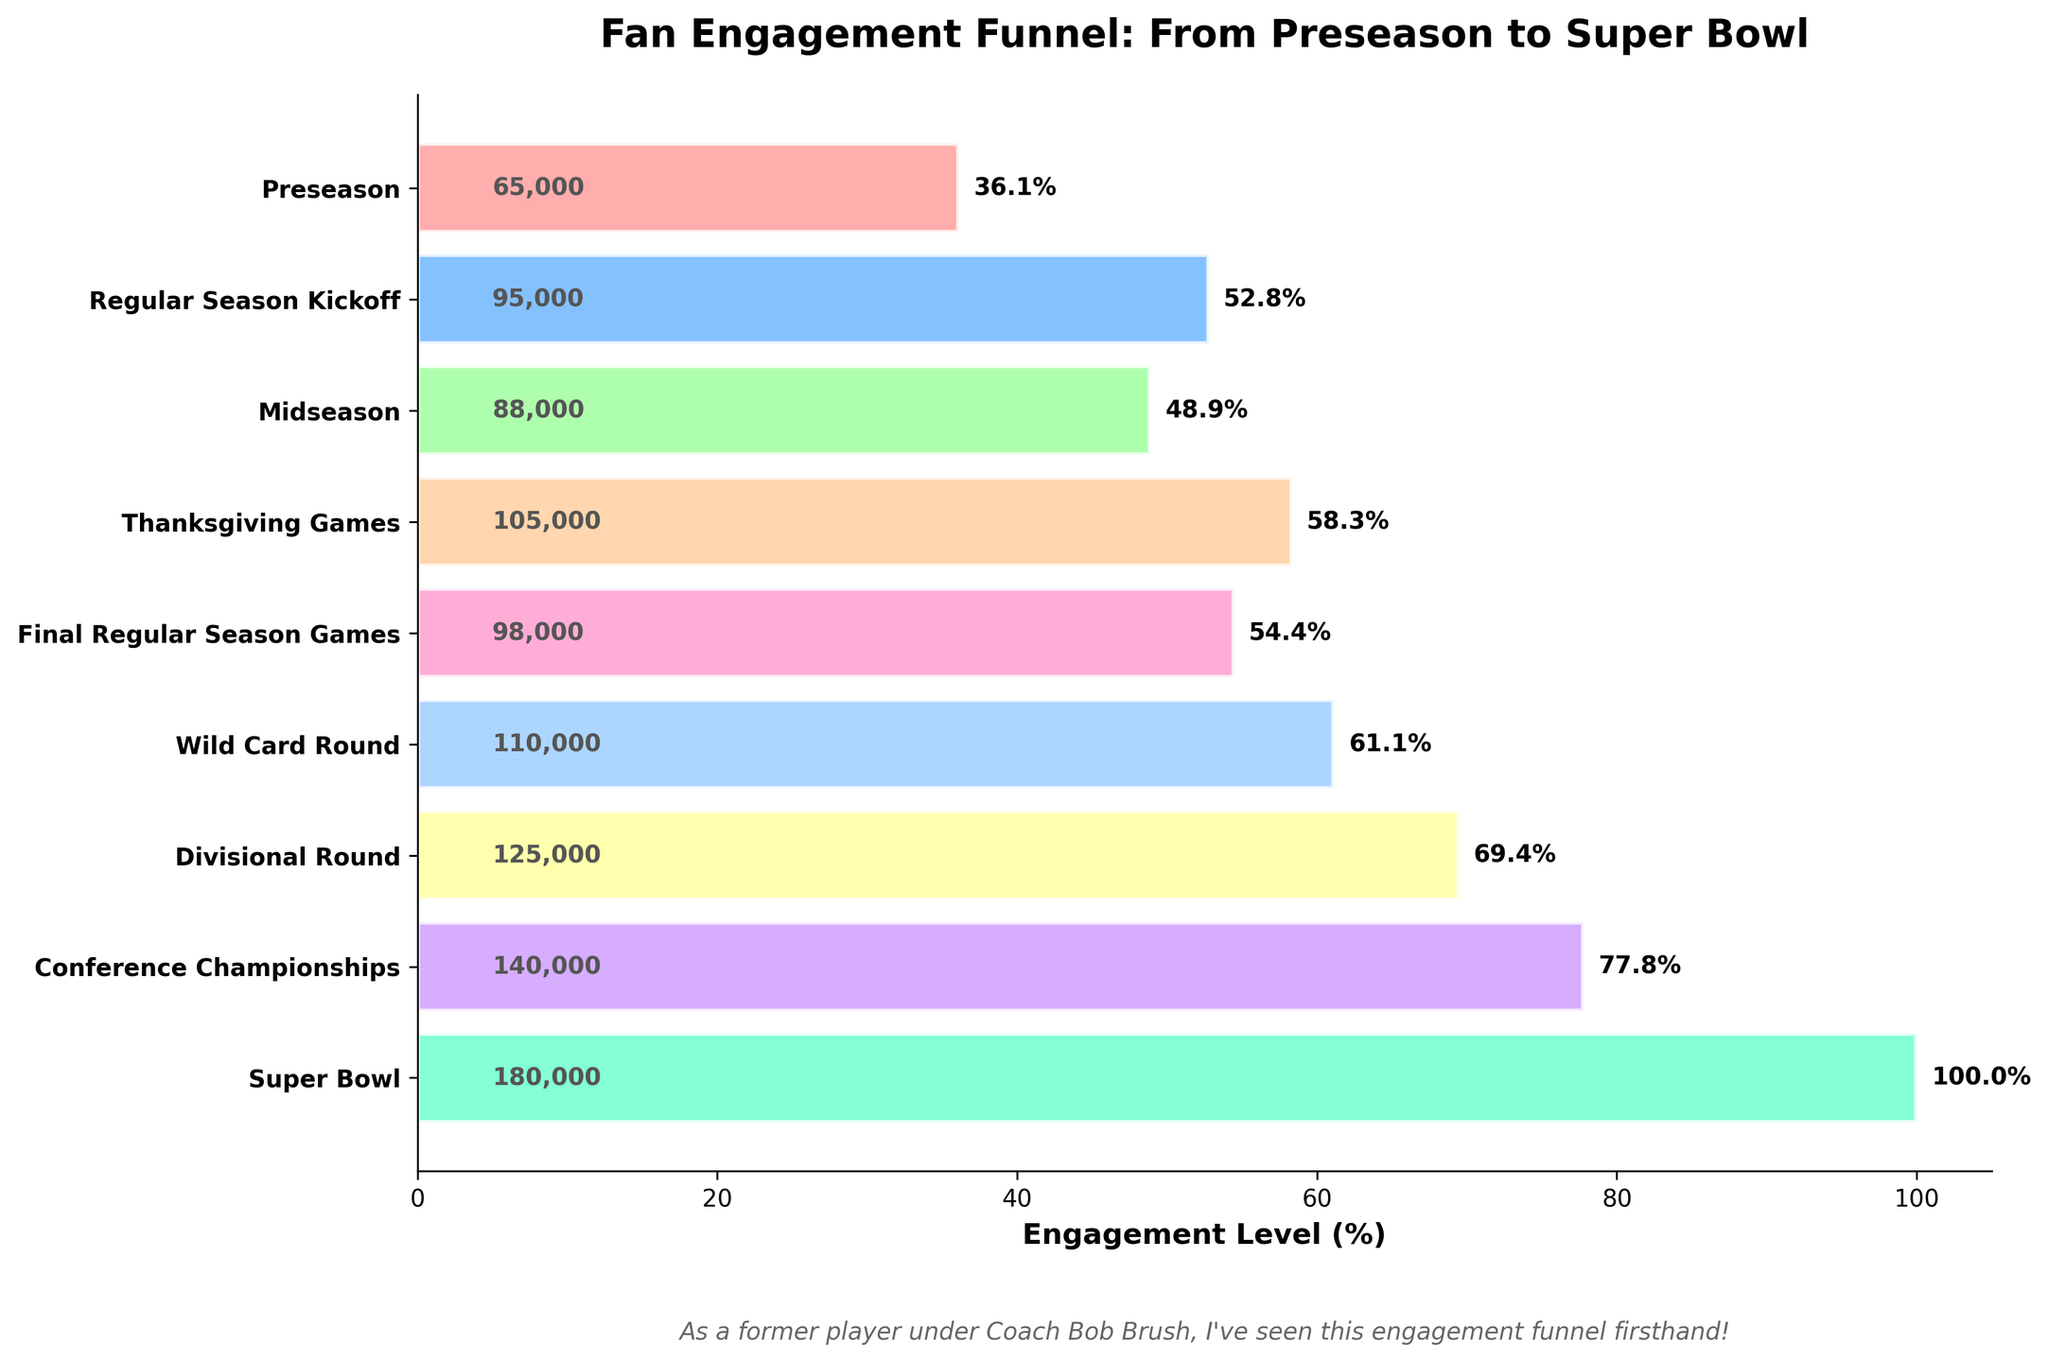what is the title of the chart? The title is located at the top of the chart and acts as a quick summary of the data visualization's purpose.
Answer: Fan Engagement Funnel: From Preseason to Super Bowl How many engagement levels are displayed? To find the number of engagement levels, count the distinct stages on the y-axis.
Answer: 9 Which stage has the highest fan engagement level? On a funnel chart, the stage with the highest engagement level will have the longest bar or the highest percentage value on the x-axis.
Answer: Super Bowl Compare the engagement levels between Thanksgiving Games and Wild Card Round. Which is higher? Locate both stages on the y-axis and compare the lengths of their corresponding bars or their percentage values.
Answer: Wild Card Round What is the difference in fan engagement levels between the Regular Season Kickoff and Midseason? Find both engagement levels on the x-axis, then subtract the Midseason value from the Regular Season Kickoff value: 95000 - 88000.
Answer: 7000 Summarize the general trend of fan engagement levels from Preseason to the Super Bowl. Look at the lengths of the bars or percentage values from top to bottom. The engagement levels generally increase as the season progresses.
Answer: Increases Between which two consecutive stages is the increase in fan engagement the smallest? Calculate the difference in engagement levels between each pair of consecutive stages and find the smallest difference.
Answer: Regular Season Kickoff and Midseason Which stage shows the highest percentage increase in fan engagement compared to its previous stage? Calculate the percentage increase between each pair of consecutive stages using the formula: (New value - Old value) / Old value * 100. Identify the highest percentage increase.
Answer: Thanksgiving Games What is the engagement level during the Conference Championships in percentage terms? Find the percentage value corresponding to the Conference Championships stage on the x-axis.
Answer: 77.8% How does fan engagement during the Divisional Round compare to that during the Wild Card Round in terms of percentage? Locate both stages on the y-axis and compare their percentage values: Divisional Round: 69.4%, Wild Card Round: 61.1%.
Answer: Higher 